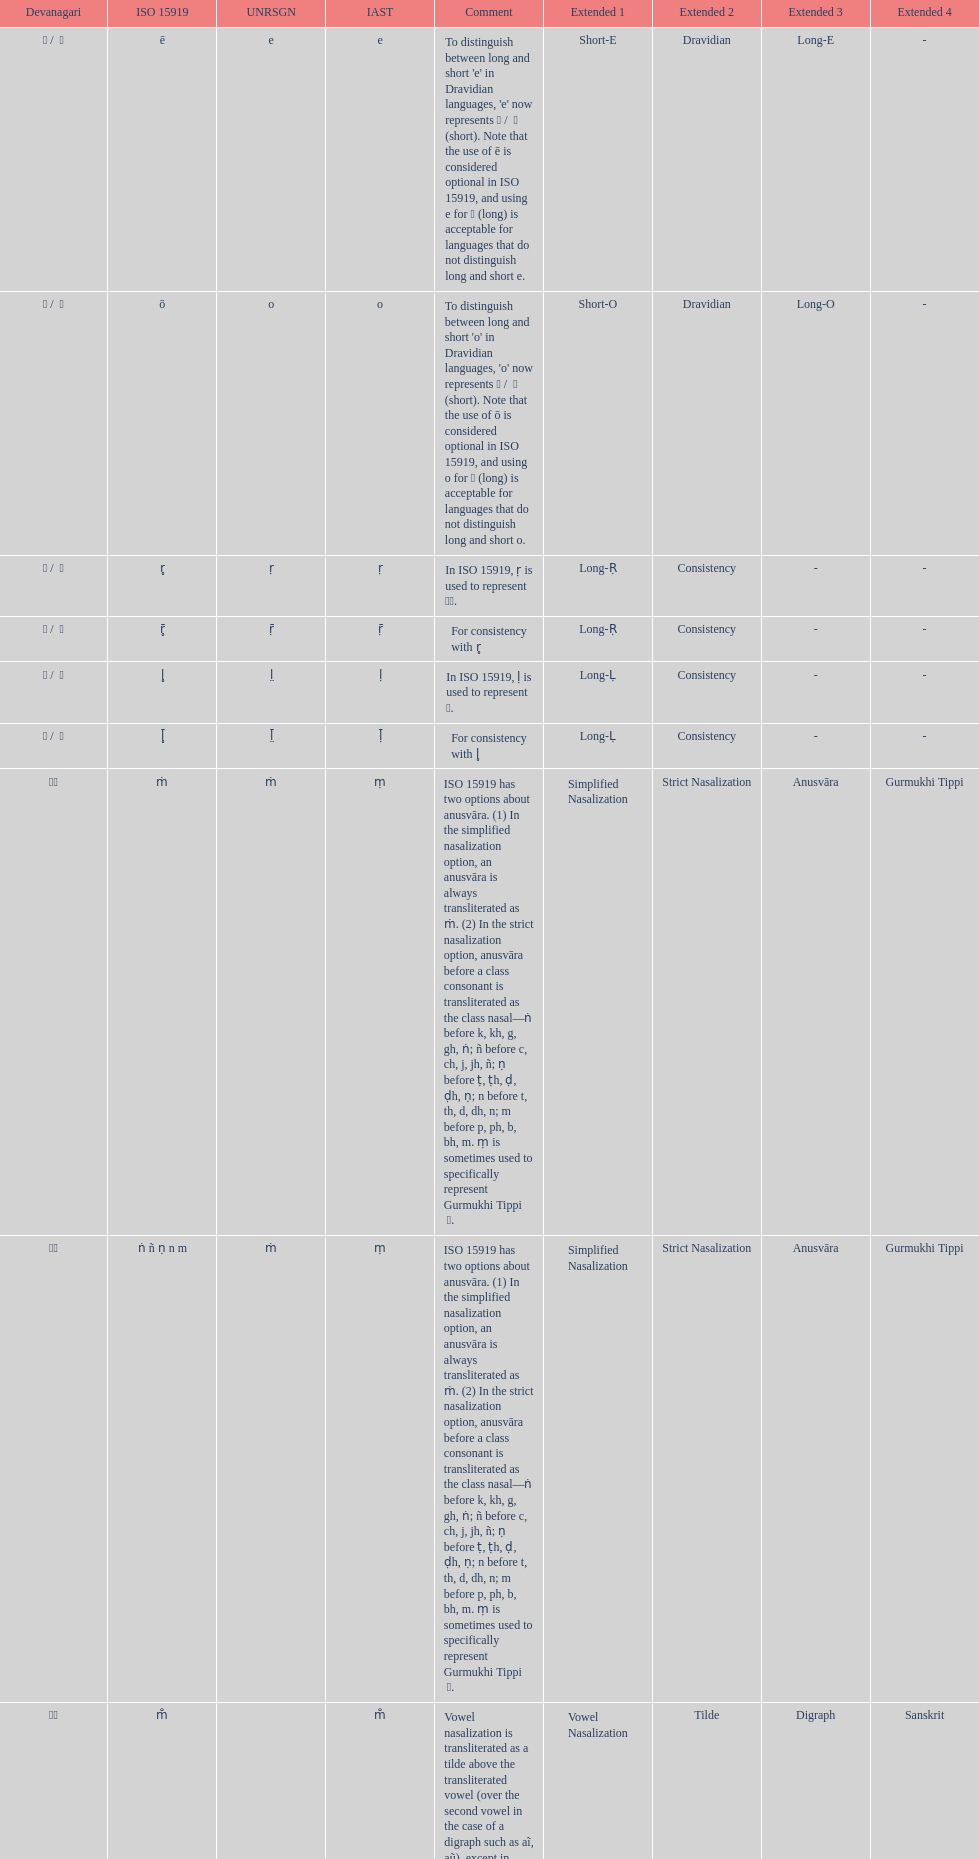What unrsgn is listed previous to the o? E. 